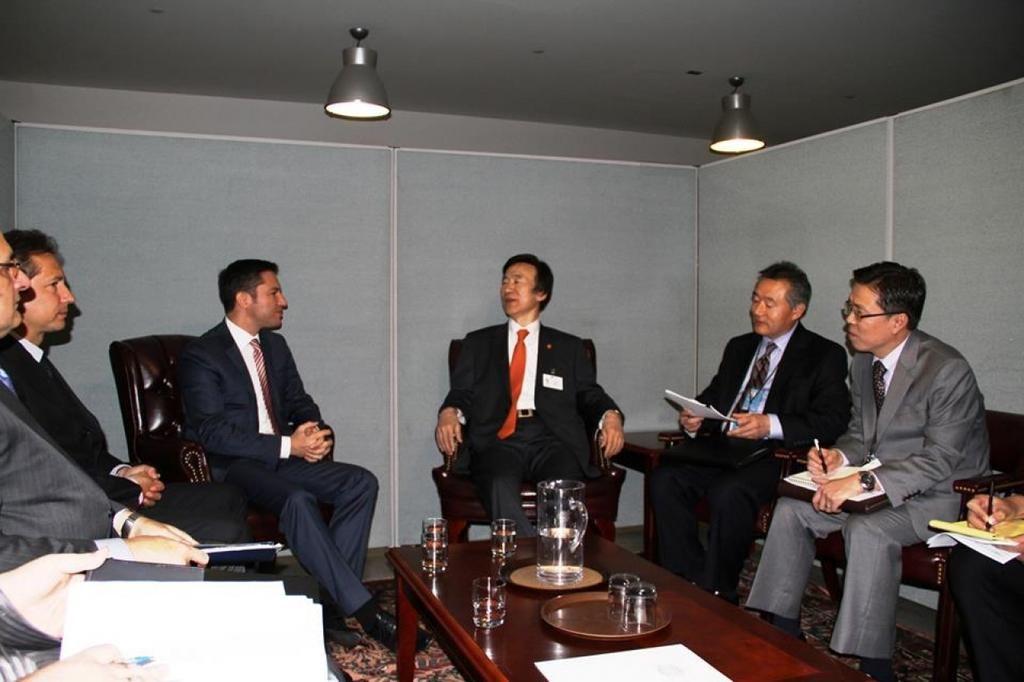How many people are in the image? There is a group of people in the image, but the exact number is not specified. What are the people doing in the image? The people are sitting on chairs in the image. How are the chairs arranged in the image? The chairs are arranged around a table in the image. What can be found on the table in the image? There are glasses and papers on the table in the image. What are the people holding in their hands? The people in the image are holding pens in their hands. What type of plastic is covering the seashore in the image? There is no plastic or seashore present in the image; it features a group of people sitting around a table with glasses, papers, and pens. 